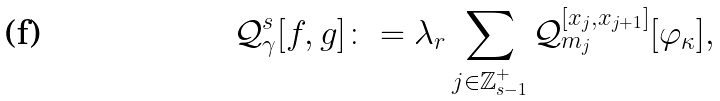Convert formula to latex. <formula><loc_0><loc_0><loc_500><loc_500>\mathcal { Q } _ { \gamma } ^ { s } [ f , g ] \colon = \lambda _ { r } \sum _ { j \in \mathbb { Z } _ { s - 1 } ^ { + } } \mathcal { Q } _ { m _ { j } } ^ { [ x _ { j } , x _ { j + 1 } ] } [ \varphi _ { \kappa } ] ,</formula> 